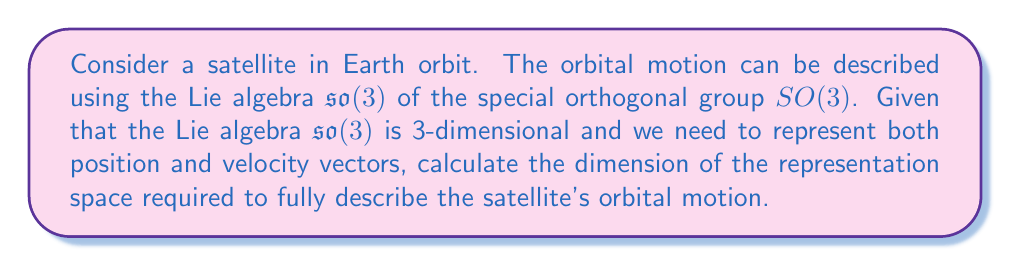Can you answer this question? To solve this problem, let's follow these steps:

1) First, recall that $\mathfrak{so}(3)$ is the Lie algebra of $SO(3)$, which represents rotations in 3D space. The dimension of $\mathfrak{so}(3)$ is 3, corresponding to rotations around the x, y, and z axes.

2) For orbital motion, we need to represent:
   a) Position vector: $\vec{r} = (x, y, z)$ (3 dimensions)
   b) Velocity vector: $\vec{v} = (v_x, v_y, v_z)$ (3 dimensions)

3) The position and velocity vectors are both elements of $\mathbb{R}^3$.

4) In Lie algebra representation theory, we often use the concept of the adjoint representation. However, for this physical system, we need a representation that can accommodate both position and velocity.

5) Therefore, we need a representation space that can contain both $\vec{r}$ and $\vec{v}$ simultaneously.

6) The dimension of this representation space will be the sum of the dimensions required for position and velocity:

   $\dim(\text{representation space}) = \dim(\vec{r}) + \dim(\vec{v}) = 3 + 3 = 6$

7) This 6-dimensional space is often referred to as the phase space in classical mechanics, which fully describes the state of the orbital system at any given time.

8) The Lie algebra $\mathfrak{so}(3)$ acts on this 6-dimensional space through its action on both the position and velocity components separately.

Therefore, the dimension of the representation space required to fully describe the satellite's orbital motion is 6.
Answer: 6 